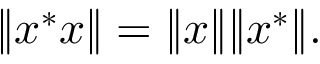Convert formula to latex. <formula><loc_0><loc_0><loc_500><loc_500>\| x ^ { * } x \| = \| x \| \| x ^ { * } \| .</formula> 